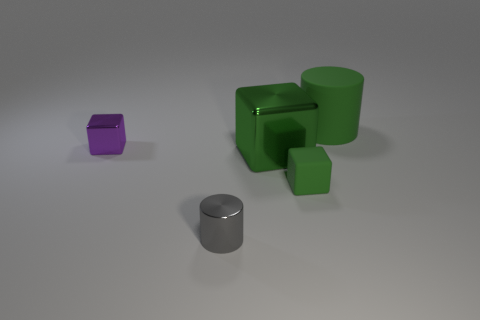Are there any big objects behind the small block that is left of the gray metallic cylinder in front of the tiny metal block?
Ensure brevity in your answer.  Yes. Is the color of the large cylinder to the right of the large green metallic object the same as the large metallic block?
Your answer should be very brief. Yes. What number of blocks are either metallic objects or yellow matte objects?
Your answer should be compact. 2. The green metallic thing left of the small thing that is on the right side of the large cube is what shape?
Your response must be concise. Cube. What is the size of the cylinder to the right of the cylinder that is in front of the rubber thing that is behind the small matte thing?
Give a very brief answer. Large. Is the size of the green matte cube the same as the gray cylinder?
Provide a short and direct response. Yes. How many objects are either large purple matte blocks or cylinders?
Your response must be concise. 2. What is the size of the shiny block to the right of the cylinder in front of the tiny purple metal thing?
Ensure brevity in your answer.  Large. What is the size of the shiny cylinder?
Provide a short and direct response. Small. What shape is the green thing that is behind the green rubber cube and in front of the green rubber cylinder?
Your response must be concise. Cube. 